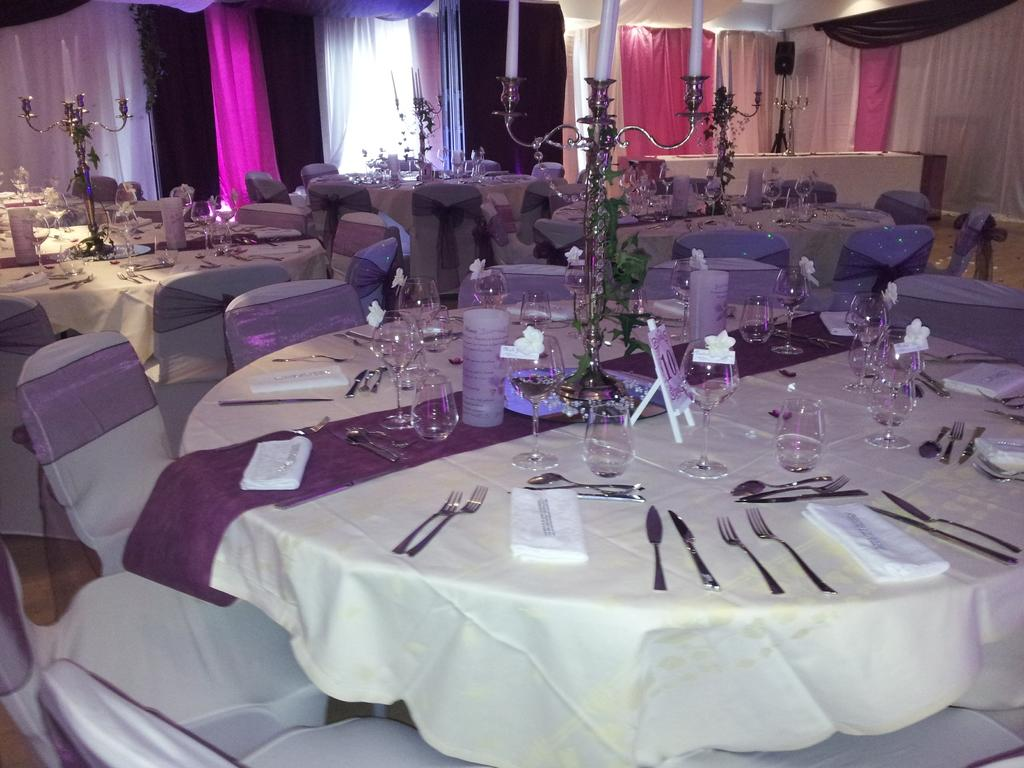What type of furniture can be seen in the image? There are chairs and tables in the image. What utensils are present on the tables? Forks, knives, and spoons are present on the tables. What type of dishware is on the tables? Glasses are present on the tables. What can be used for cleaning or wiping in the image? Tissue papers are on the tables. What decorative items are on the tables? Candle stands are on the tables. What can be seen in the background of the image? There are curtains and a speaker in the background of the image. What type of blood is visible on the chairs in the image? There is no blood visible on the chairs in the image. What substance is being consumed by the friends in the image? There is no indication of friends or any substance being consumed in the image. 